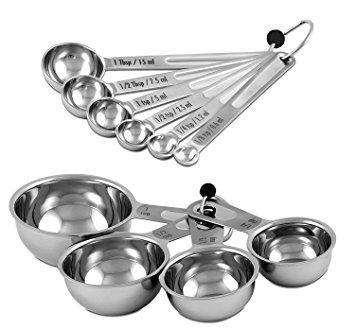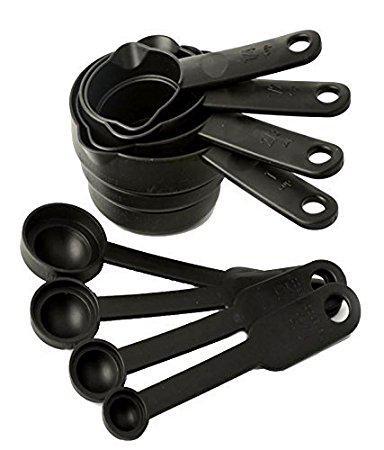The first image is the image on the left, the second image is the image on the right. Evaluate the accuracy of this statement regarding the images: "One image contains a multicolored measuring set". Is it true? Answer yes or no. No. 